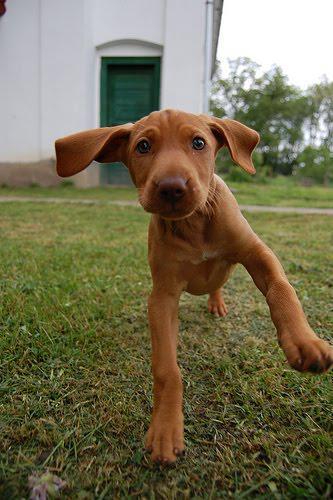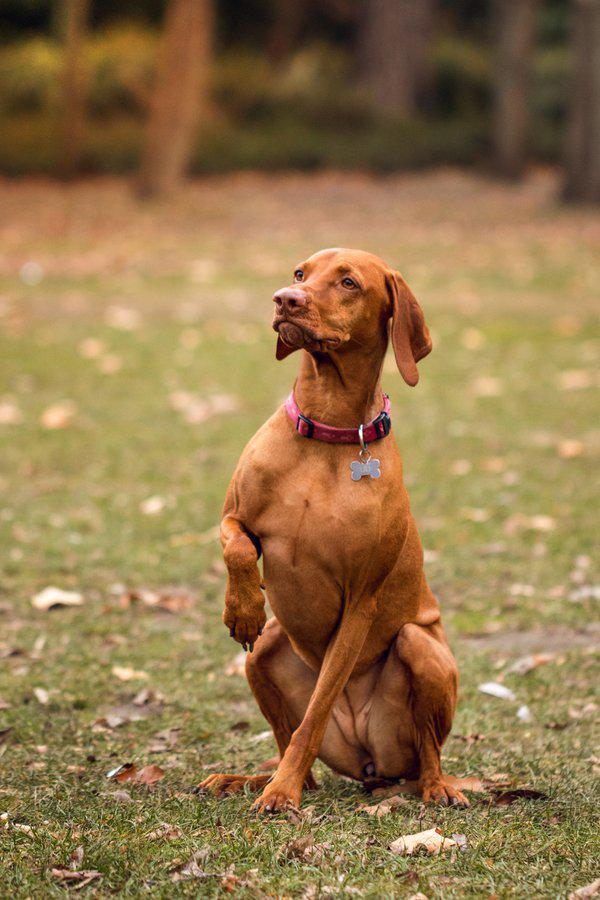The first image is the image on the left, the second image is the image on the right. Considering the images on both sides, is "At least one dog has its mouth open." valid? Answer yes or no. No. The first image is the image on the left, the second image is the image on the right. For the images shown, is this caption "The lefthand dog has long floppy ears and is turned slightly leftward, and the righthand dog has its head turned slightly rightward." true? Answer yes or no. No. 